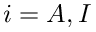<formula> <loc_0><loc_0><loc_500><loc_500>i = A , I</formula> 